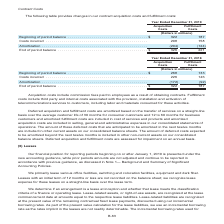According to Centurylink's financial document, What do the fulfillment costs include? third party and internal costs associated with the provision, installation and activation of telecommunications services to customers, including labor and materials consumed for these activities.. The document states: "of obtaining contracts. Fulfillment costs include third party and internal costs associated with the provision, installation and activation of telecom..." Also, How are the deferred acquisition and fulfillment costs amortized? based on the transfer of services on a straight-line basis over the average customer life of 30 months for consumer customers and 12 to 60 months for business customers. The document states: "d acquisition and fulfillment costs are amortized based on the transfer of services on a straight-line basis over the average customer life of 30 mont..." Also, What are the types of costs highlighted in the table? The document shows two values: Acquisition costs and Fulfillment Costs. From the document: "to employees as a result of obtaining contracts. Fulfillment costs include third party and internal costs associated with the provision, installation ..." Additionally, Which type of costs has a larger amount under costs incurred? According to the financial document, Acquisition Costs. The relevant text states: "Acquisition costs include commission fees paid to employees as a result of obtaining contracts. Fulfillment costs inc..." Also, can you calculate: What is the sum of the end of period balance costs for 2019? Based on the calculation: 326+221, the result is 547 (in millions). This is based on the information: "End of period balance . $ 326 221 End of period balance . $ 326 221..." The key data points involved are: 221, 326. Also, can you calculate: What is the percentage change for the end of period balance for Fulfillment Costs when comparing the beginning of period balance? To answer this question, I need to perform calculations using the financial data. The calculation is: (221-187)/187, which equals 18.18 (percentage). This is based on the information: "End of period balance . $ 326 221 in millions) Beginning of period balance . $ 322 187 Costs incurred . 208 158 Amortization . (204) (124)..." The key data points involved are: 187, 221. 